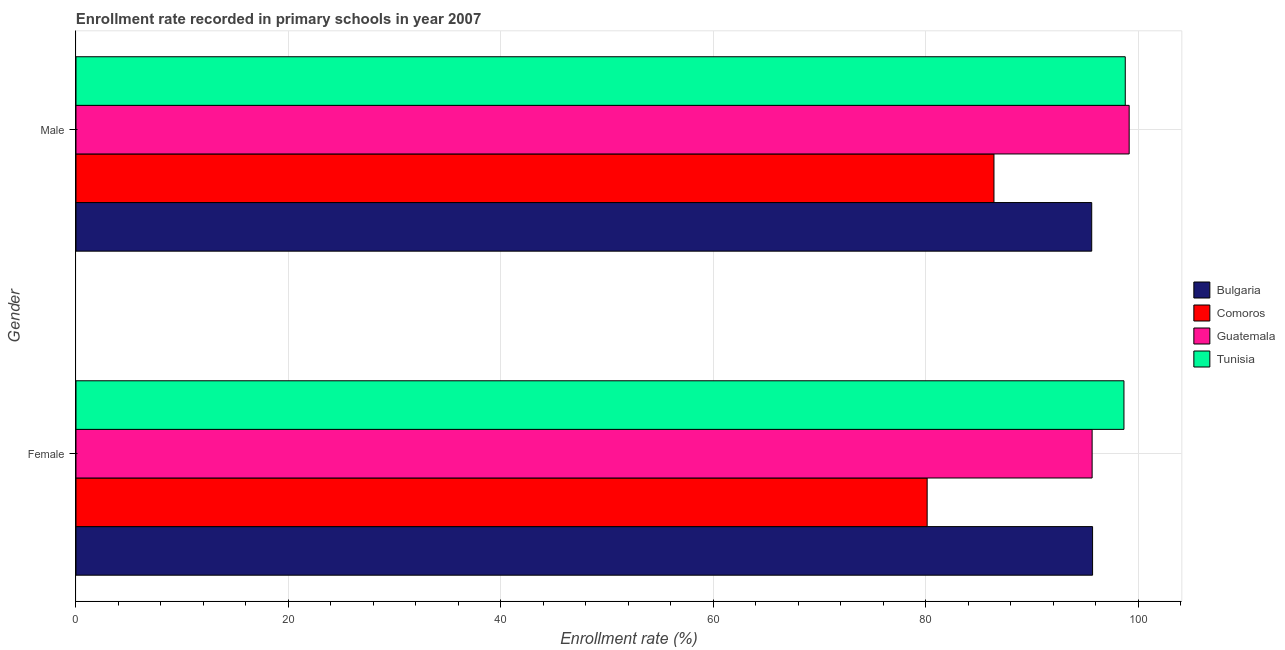How many bars are there on the 1st tick from the bottom?
Provide a succinct answer. 4. What is the label of the 1st group of bars from the top?
Provide a succinct answer. Male. What is the enrollment rate of female students in Guatemala?
Your answer should be compact. 95.67. Across all countries, what is the maximum enrollment rate of female students?
Provide a succinct answer. 98.67. Across all countries, what is the minimum enrollment rate of female students?
Your answer should be compact. 80.14. In which country was the enrollment rate of female students maximum?
Ensure brevity in your answer.  Tunisia. In which country was the enrollment rate of male students minimum?
Provide a short and direct response. Comoros. What is the total enrollment rate of male students in the graph?
Provide a succinct answer. 380.01. What is the difference between the enrollment rate of female students in Tunisia and that in Bulgaria?
Provide a succinct answer. 2.95. What is the difference between the enrollment rate of male students in Guatemala and the enrollment rate of female students in Bulgaria?
Offer a very short reply. 3.45. What is the average enrollment rate of female students per country?
Your response must be concise. 92.55. What is the difference between the enrollment rate of female students and enrollment rate of male students in Guatemala?
Give a very brief answer. -3.49. What is the ratio of the enrollment rate of female students in Bulgaria to that in Tunisia?
Your response must be concise. 0.97. Is the enrollment rate of female students in Tunisia less than that in Comoros?
Keep it short and to the point. No. What does the 1st bar from the top in Female represents?
Your response must be concise. Tunisia. How many bars are there?
Offer a very short reply. 8. How many countries are there in the graph?
Your answer should be compact. 4. How many legend labels are there?
Offer a very short reply. 4. What is the title of the graph?
Your answer should be compact. Enrollment rate recorded in primary schools in year 2007. What is the label or title of the X-axis?
Provide a succinct answer. Enrollment rate (%). What is the label or title of the Y-axis?
Make the answer very short. Gender. What is the Enrollment rate (%) in Bulgaria in Female?
Make the answer very short. 95.71. What is the Enrollment rate (%) in Comoros in Female?
Provide a succinct answer. 80.14. What is the Enrollment rate (%) of Guatemala in Female?
Provide a succinct answer. 95.67. What is the Enrollment rate (%) of Tunisia in Female?
Keep it short and to the point. 98.67. What is the Enrollment rate (%) in Bulgaria in Male?
Ensure brevity in your answer.  95.63. What is the Enrollment rate (%) in Comoros in Male?
Your answer should be compact. 86.43. What is the Enrollment rate (%) in Guatemala in Male?
Your answer should be very brief. 99.16. What is the Enrollment rate (%) of Tunisia in Male?
Give a very brief answer. 98.79. Across all Gender, what is the maximum Enrollment rate (%) in Bulgaria?
Ensure brevity in your answer.  95.71. Across all Gender, what is the maximum Enrollment rate (%) of Comoros?
Make the answer very short. 86.43. Across all Gender, what is the maximum Enrollment rate (%) in Guatemala?
Your answer should be very brief. 99.16. Across all Gender, what is the maximum Enrollment rate (%) of Tunisia?
Provide a succinct answer. 98.79. Across all Gender, what is the minimum Enrollment rate (%) of Bulgaria?
Give a very brief answer. 95.63. Across all Gender, what is the minimum Enrollment rate (%) in Comoros?
Ensure brevity in your answer.  80.14. Across all Gender, what is the minimum Enrollment rate (%) in Guatemala?
Ensure brevity in your answer.  95.67. Across all Gender, what is the minimum Enrollment rate (%) in Tunisia?
Your response must be concise. 98.67. What is the total Enrollment rate (%) of Bulgaria in the graph?
Provide a short and direct response. 191.34. What is the total Enrollment rate (%) of Comoros in the graph?
Make the answer very short. 166.57. What is the total Enrollment rate (%) of Guatemala in the graph?
Offer a terse response. 194.83. What is the total Enrollment rate (%) in Tunisia in the graph?
Your response must be concise. 197.46. What is the difference between the Enrollment rate (%) in Bulgaria in Female and that in Male?
Keep it short and to the point. 0.08. What is the difference between the Enrollment rate (%) in Comoros in Female and that in Male?
Ensure brevity in your answer.  -6.29. What is the difference between the Enrollment rate (%) of Guatemala in Female and that in Male?
Provide a succinct answer. -3.49. What is the difference between the Enrollment rate (%) in Tunisia in Female and that in Male?
Ensure brevity in your answer.  -0.12. What is the difference between the Enrollment rate (%) of Bulgaria in Female and the Enrollment rate (%) of Comoros in Male?
Provide a succinct answer. 9.28. What is the difference between the Enrollment rate (%) of Bulgaria in Female and the Enrollment rate (%) of Guatemala in Male?
Keep it short and to the point. -3.45. What is the difference between the Enrollment rate (%) of Bulgaria in Female and the Enrollment rate (%) of Tunisia in Male?
Offer a terse response. -3.08. What is the difference between the Enrollment rate (%) of Comoros in Female and the Enrollment rate (%) of Guatemala in Male?
Provide a succinct answer. -19.02. What is the difference between the Enrollment rate (%) of Comoros in Female and the Enrollment rate (%) of Tunisia in Male?
Make the answer very short. -18.65. What is the difference between the Enrollment rate (%) of Guatemala in Female and the Enrollment rate (%) of Tunisia in Male?
Keep it short and to the point. -3.12. What is the average Enrollment rate (%) in Bulgaria per Gender?
Make the answer very short. 95.67. What is the average Enrollment rate (%) in Comoros per Gender?
Make the answer very short. 83.28. What is the average Enrollment rate (%) of Guatemala per Gender?
Keep it short and to the point. 97.41. What is the average Enrollment rate (%) of Tunisia per Gender?
Make the answer very short. 98.73. What is the difference between the Enrollment rate (%) in Bulgaria and Enrollment rate (%) in Comoros in Female?
Ensure brevity in your answer.  15.57. What is the difference between the Enrollment rate (%) in Bulgaria and Enrollment rate (%) in Guatemala in Female?
Your response must be concise. 0.04. What is the difference between the Enrollment rate (%) of Bulgaria and Enrollment rate (%) of Tunisia in Female?
Give a very brief answer. -2.95. What is the difference between the Enrollment rate (%) of Comoros and Enrollment rate (%) of Guatemala in Female?
Provide a succinct answer. -15.53. What is the difference between the Enrollment rate (%) of Comoros and Enrollment rate (%) of Tunisia in Female?
Provide a short and direct response. -18.53. What is the difference between the Enrollment rate (%) in Guatemala and Enrollment rate (%) in Tunisia in Female?
Ensure brevity in your answer.  -3. What is the difference between the Enrollment rate (%) in Bulgaria and Enrollment rate (%) in Comoros in Male?
Make the answer very short. 9.2. What is the difference between the Enrollment rate (%) of Bulgaria and Enrollment rate (%) of Guatemala in Male?
Offer a terse response. -3.53. What is the difference between the Enrollment rate (%) in Bulgaria and Enrollment rate (%) in Tunisia in Male?
Keep it short and to the point. -3.16. What is the difference between the Enrollment rate (%) in Comoros and Enrollment rate (%) in Guatemala in Male?
Your answer should be compact. -12.73. What is the difference between the Enrollment rate (%) of Comoros and Enrollment rate (%) of Tunisia in Male?
Offer a very short reply. -12.36. What is the difference between the Enrollment rate (%) of Guatemala and Enrollment rate (%) of Tunisia in Male?
Provide a succinct answer. 0.37. What is the ratio of the Enrollment rate (%) of Comoros in Female to that in Male?
Provide a succinct answer. 0.93. What is the ratio of the Enrollment rate (%) of Guatemala in Female to that in Male?
Give a very brief answer. 0.96. What is the difference between the highest and the second highest Enrollment rate (%) in Bulgaria?
Keep it short and to the point. 0.08. What is the difference between the highest and the second highest Enrollment rate (%) of Comoros?
Provide a short and direct response. 6.29. What is the difference between the highest and the second highest Enrollment rate (%) in Guatemala?
Provide a succinct answer. 3.49. What is the difference between the highest and the second highest Enrollment rate (%) in Tunisia?
Offer a terse response. 0.12. What is the difference between the highest and the lowest Enrollment rate (%) in Bulgaria?
Provide a succinct answer. 0.08. What is the difference between the highest and the lowest Enrollment rate (%) of Comoros?
Provide a short and direct response. 6.29. What is the difference between the highest and the lowest Enrollment rate (%) of Guatemala?
Give a very brief answer. 3.49. What is the difference between the highest and the lowest Enrollment rate (%) in Tunisia?
Make the answer very short. 0.12. 